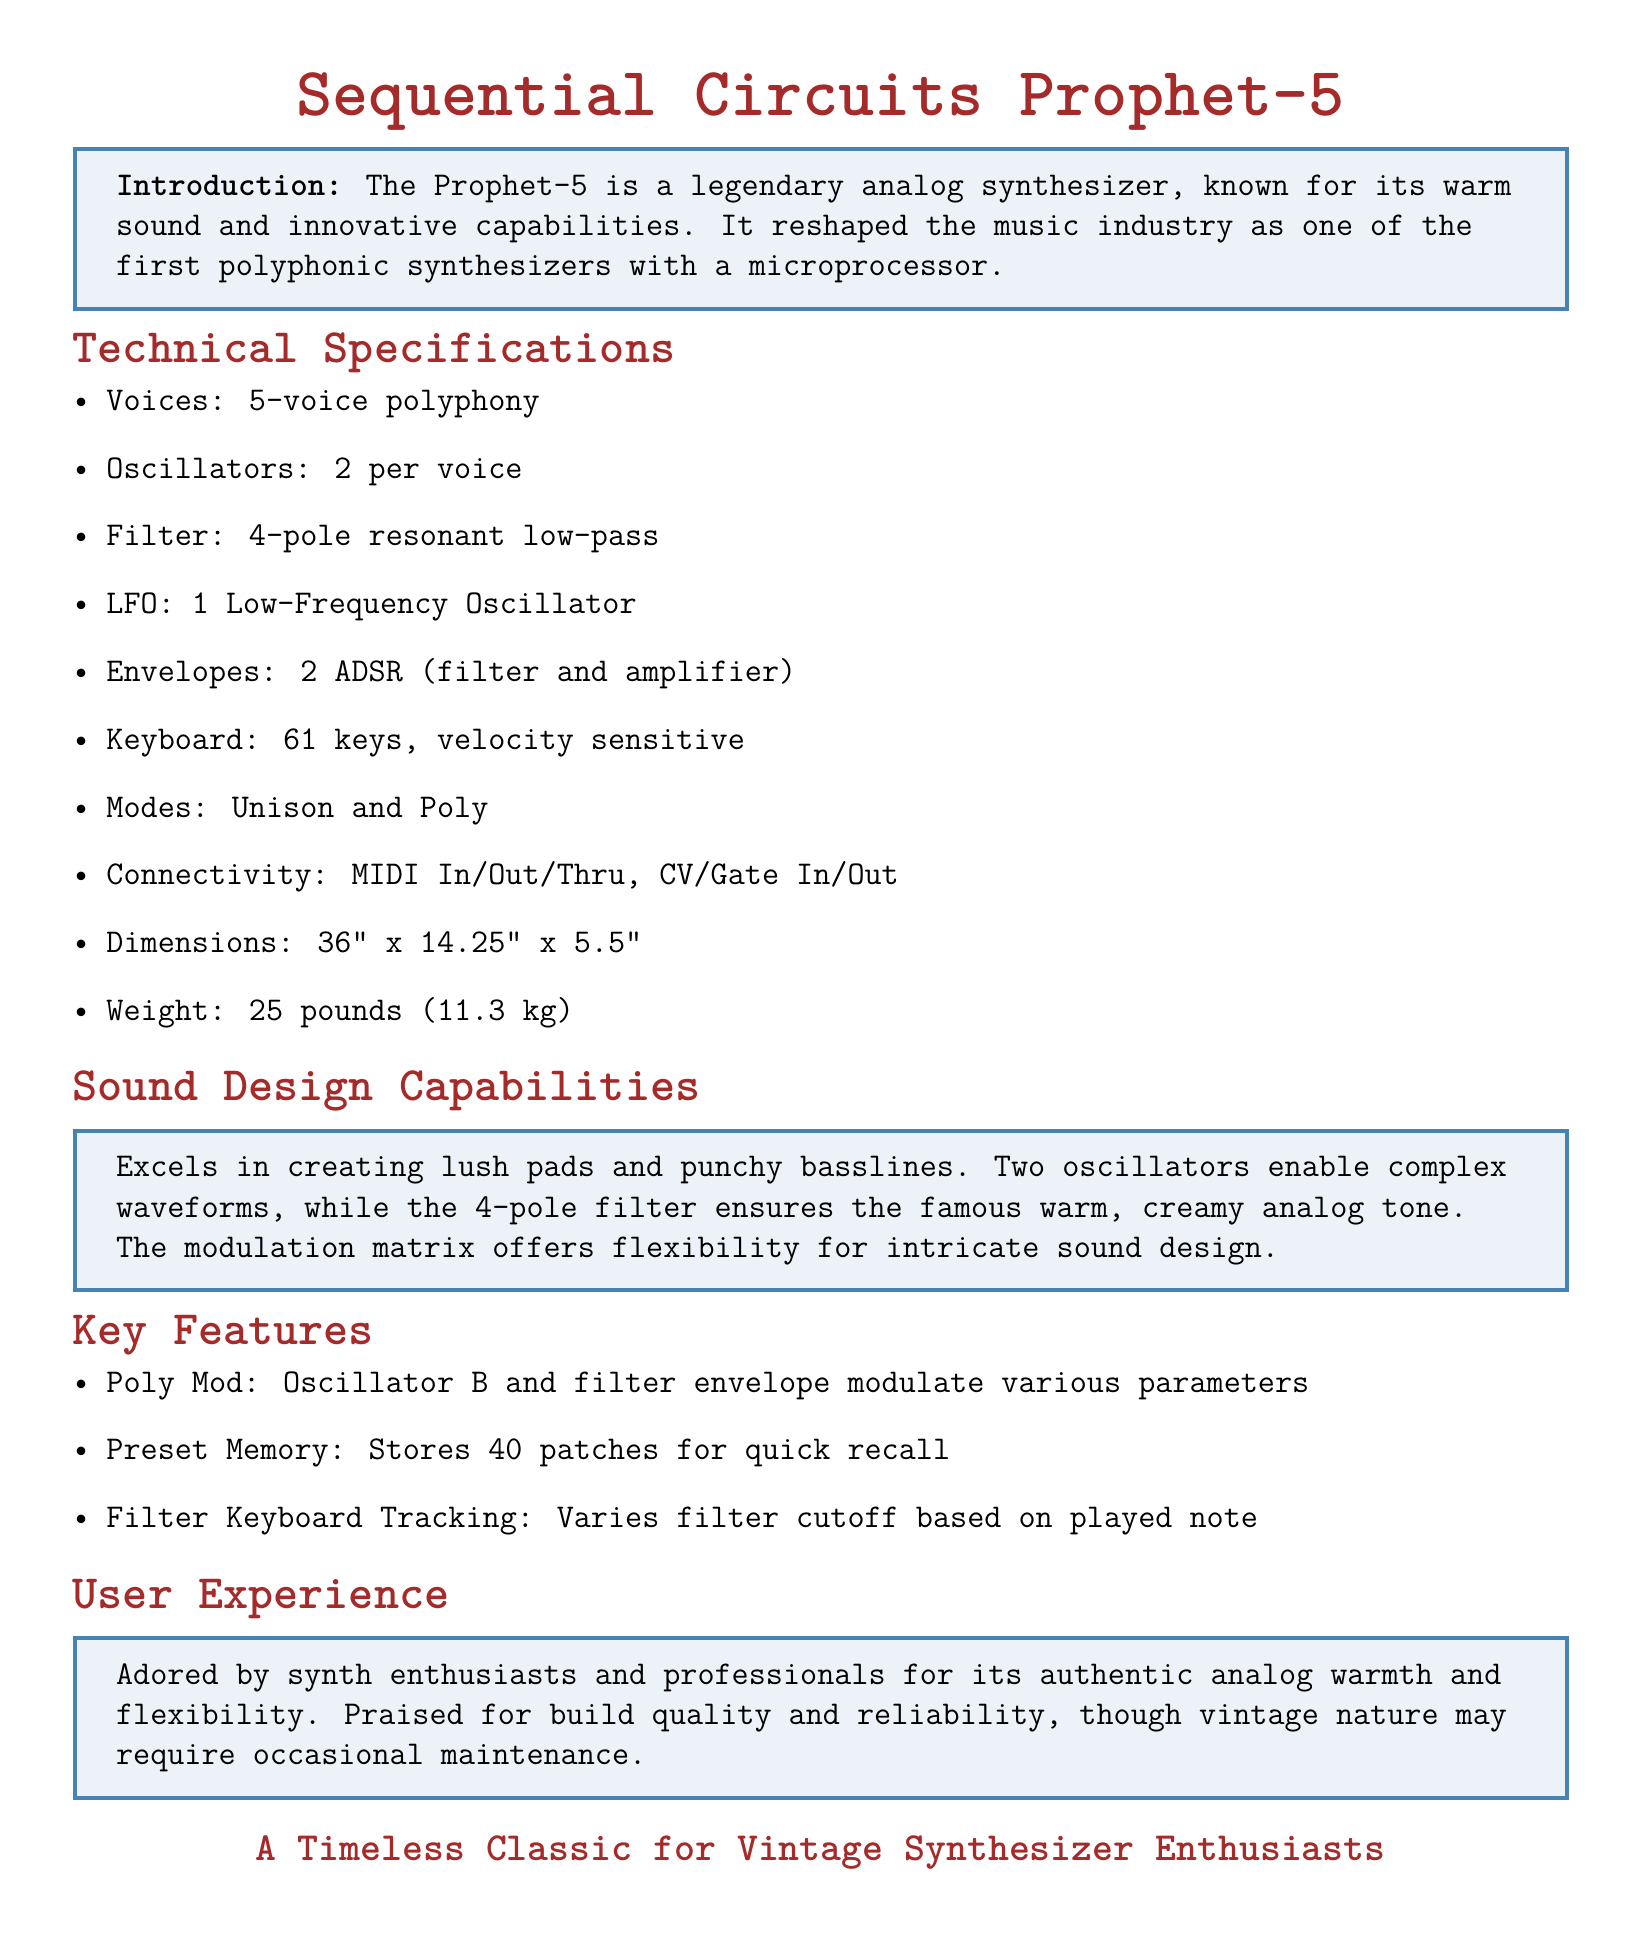What is the polyphony of the Prophet-5? The polyphony refers to the number of voices the synth can produce simultaneously, which is stated as 5-voice polyphony in the specifications.
Answer: 5-voice polyphony How many oscillators does each voice have? The document specifies that there are 2 oscillators per voice, giving an idea of the synthesizer's sound complexity.
Answer: 2 What type of filter is included? The filter type is explicitly mentioned in the specifications as a 4-pole resonant low-pass filter, indicating its sound characteristics.
Answer: 4-pole resonant low-pass How many presets can the Prophet-5 store? The information indicates storage capability, specifically mentioning the number of patches available for recall, which is noted as 40 in the document.
Answer: 40 What is one of the key sound design capabilities of the Prophet-5? The document highlights its ability to create lush pads as a notable sound design capability, emphasizing its strengths in sound production.
Answer: Lush pads What is a famous feature related to its modulation? The document mentions a specific feature called Poly Mod, which relates to the modulation capabilities of the synth, highlighting its unique characteristic.
Answer: Poly Mod What is the weight of the Prophet-5? The weight is a technical specification included in the document, allowing for understanding of its portability and build.
Answer: 25 pounds What do users praise about the Prophet-5? User experience feedback in the document mentions authentic analog warmth, which reflects the synth's performance and character in sound.
Answer: Authentic analog warmth 